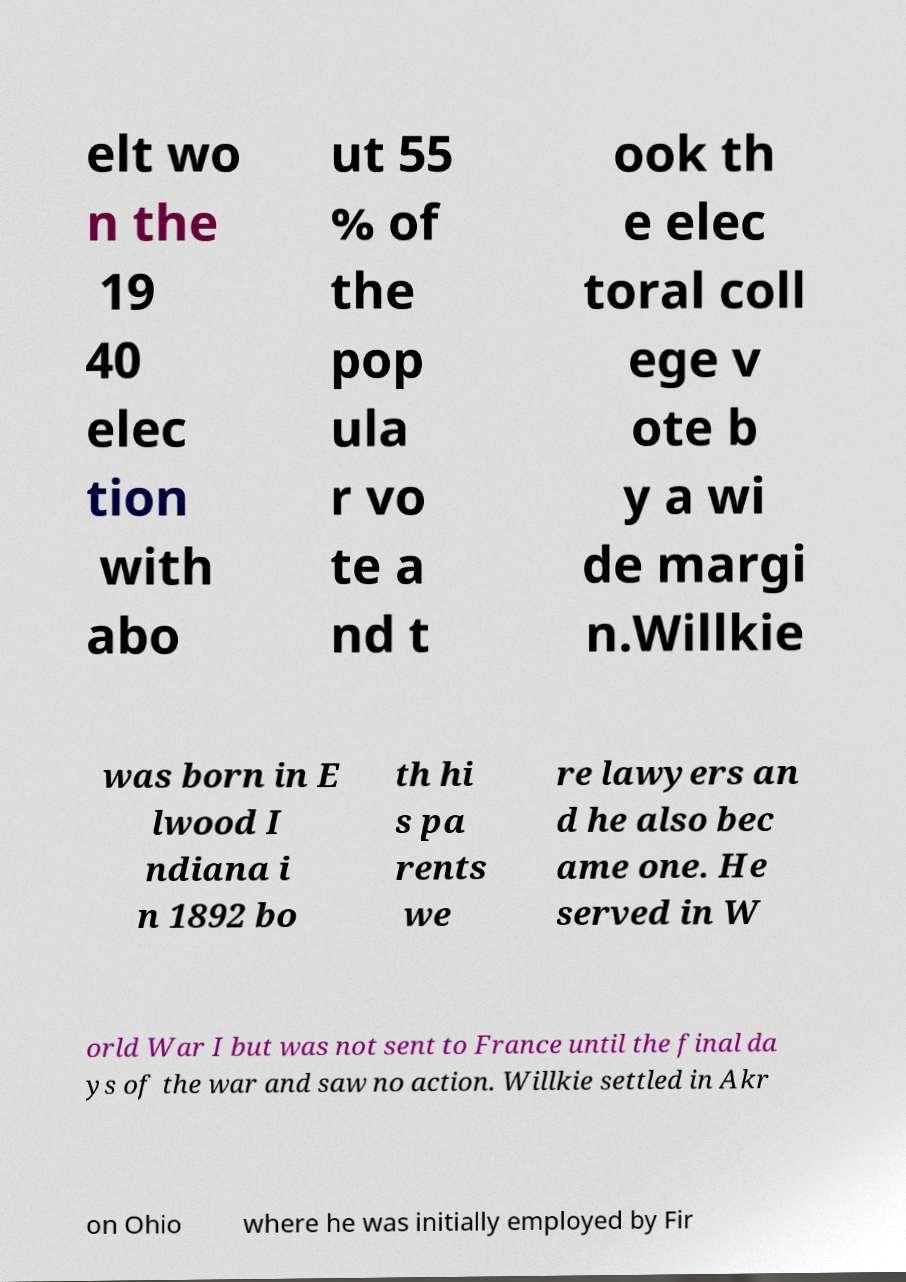I need the written content from this picture converted into text. Can you do that? elt wo n the 19 40 elec tion with abo ut 55 % of the pop ula r vo te a nd t ook th e elec toral coll ege v ote b y a wi de margi n.Willkie was born in E lwood I ndiana i n 1892 bo th hi s pa rents we re lawyers an d he also bec ame one. He served in W orld War I but was not sent to France until the final da ys of the war and saw no action. Willkie settled in Akr on Ohio where he was initially employed by Fir 